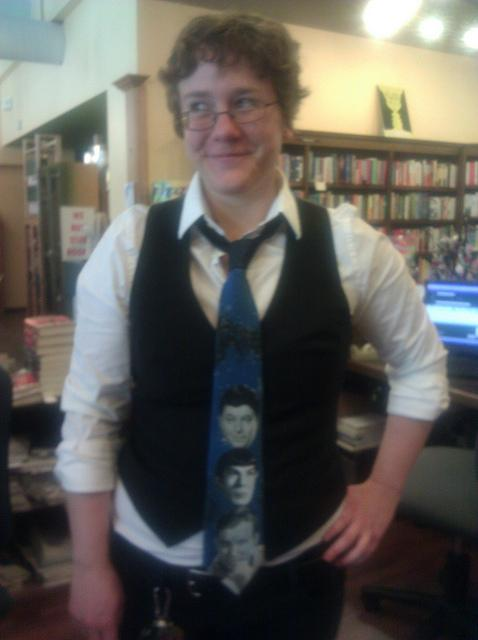What type of shop is the person wearing the tie in? book 